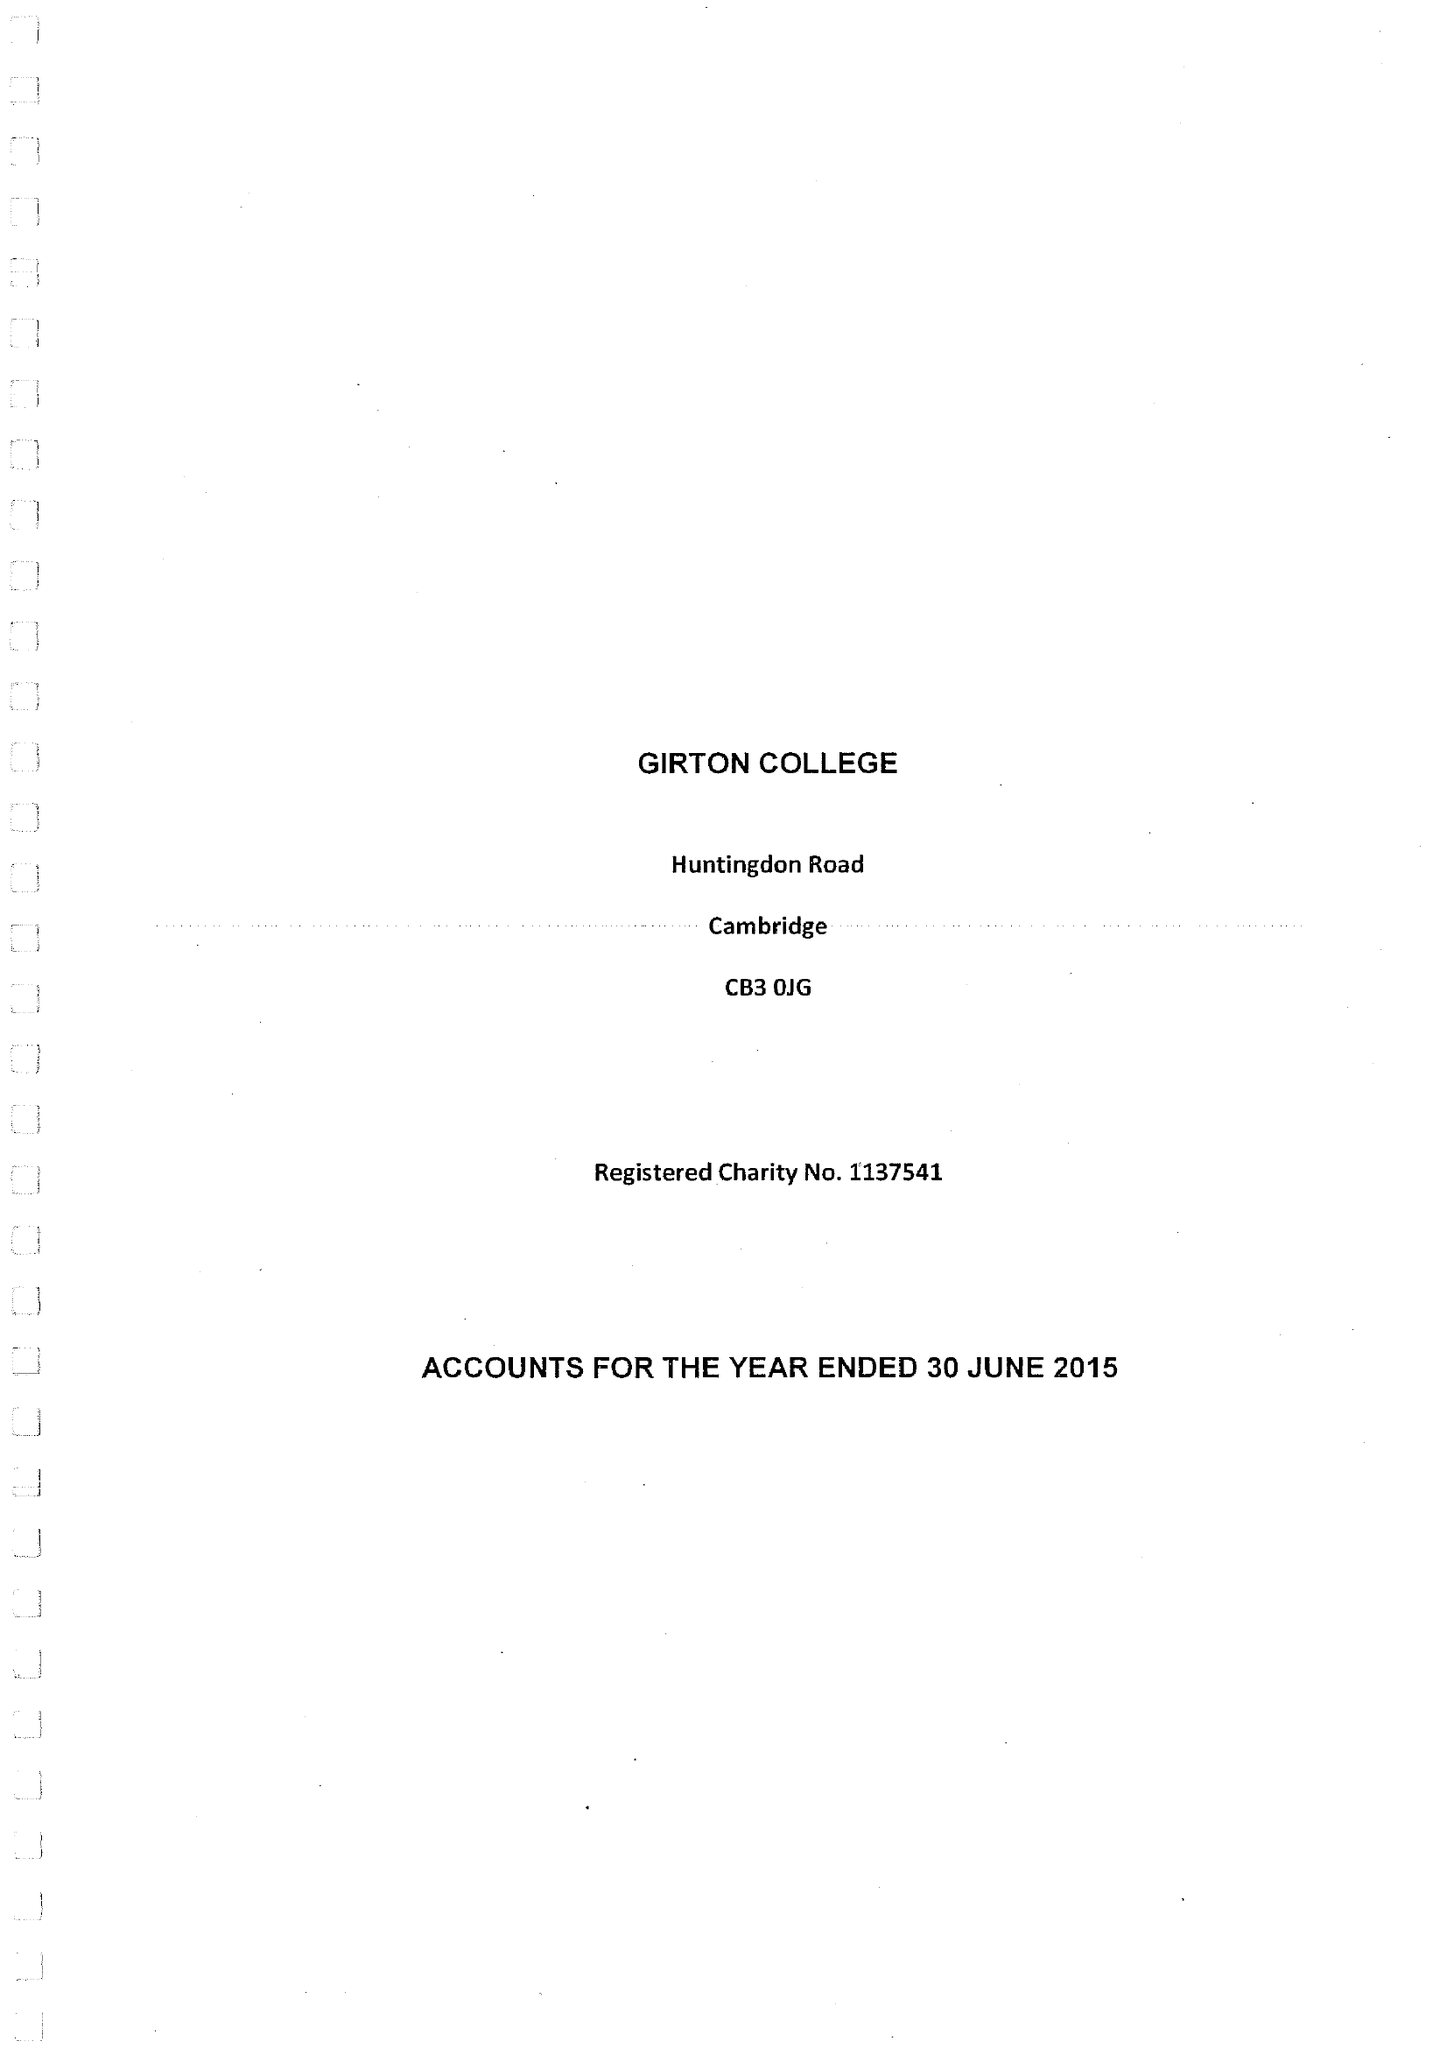What is the value for the spending_annually_in_british_pounds?
Answer the question using a single word or phrase. 11168000.00 